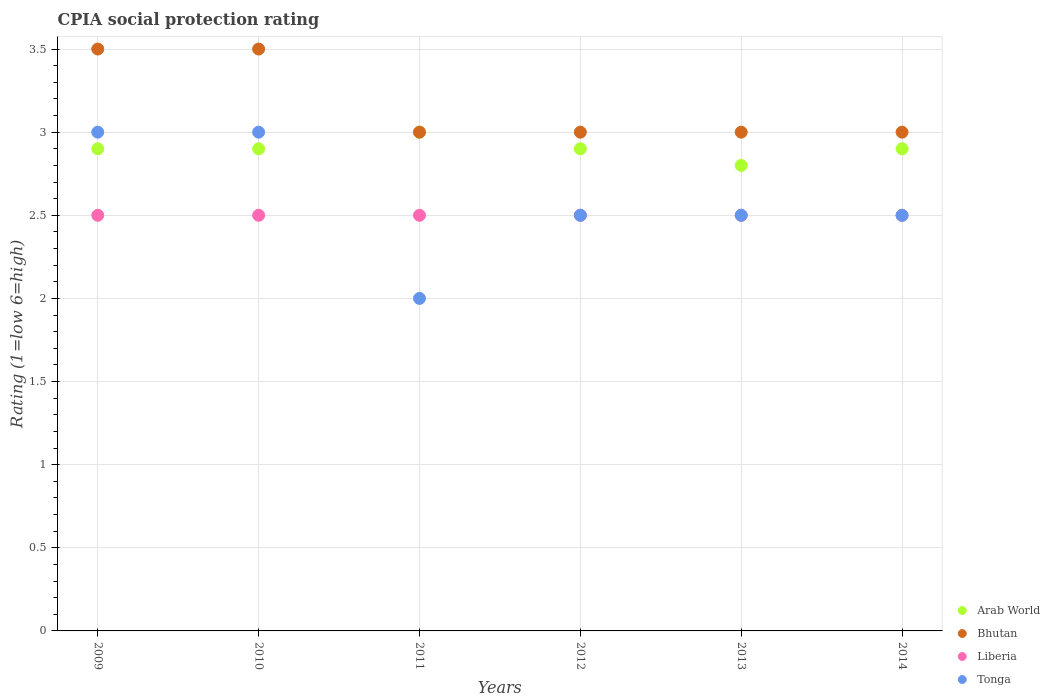How many different coloured dotlines are there?
Offer a terse response. 4. Across all years, what is the maximum CPIA rating in Bhutan?
Your answer should be very brief. 3.5. In which year was the CPIA rating in Liberia maximum?
Give a very brief answer. 2009. In which year was the CPIA rating in Arab World minimum?
Make the answer very short. 2013. What is the difference between the CPIA rating in Arab World in 2013 and that in 2014?
Keep it short and to the point. -0.1. What is the average CPIA rating in Tonga per year?
Give a very brief answer. 2.58. In the year 2011, what is the difference between the CPIA rating in Bhutan and CPIA rating in Tonga?
Ensure brevity in your answer.  1. What is the ratio of the CPIA rating in Arab World in 2010 to that in 2011?
Keep it short and to the point. 0.97. Is the CPIA rating in Arab World in 2013 less than that in 2014?
Your answer should be very brief. Yes. Is the difference between the CPIA rating in Bhutan in 2012 and 2013 greater than the difference between the CPIA rating in Tonga in 2012 and 2013?
Offer a terse response. No. What is the difference between the highest and the second highest CPIA rating in Liberia?
Give a very brief answer. 0. What is the difference between the highest and the lowest CPIA rating in Arab World?
Give a very brief answer. 0.2. In how many years, is the CPIA rating in Tonga greater than the average CPIA rating in Tonga taken over all years?
Ensure brevity in your answer.  2. Is it the case that in every year, the sum of the CPIA rating in Bhutan and CPIA rating in Tonga  is greater than the sum of CPIA rating in Liberia and CPIA rating in Arab World?
Make the answer very short. No. Does the CPIA rating in Arab World monotonically increase over the years?
Offer a very short reply. No. Is the CPIA rating in Bhutan strictly less than the CPIA rating in Arab World over the years?
Give a very brief answer. No. How many dotlines are there?
Your answer should be very brief. 4. Are the values on the major ticks of Y-axis written in scientific E-notation?
Your answer should be very brief. No. Does the graph contain any zero values?
Your answer should be compact. No. Does the graph contain grids?
Your response must be concise. Yes. How are the legend labels stacked?
Your answer should be compact. Vertical. What is the title of the graph?
Provide a succinct answer. CPIA social protection rating. What is the label or title of the X-axis?
Keep it short and to the point. Years. What is the label or title of the Y-axis?
Give a very brief answer. Rating (1=low 6=high). What is the Rating (1=low 6=high) in Tonga in 2010?
Your response must be concise. 3. What is the Rating (1=low 6=high) of Arab World in 2011?
Keep it short and to the point. 3. What is the Rating (1=low 6=high) of Bhutan in 2011?
Your answer should be compact. 3. What is the Rating (1=low 6=high) of Tonga in 2011?
Provide a short and direct response. 2. What is the Rating (1=low 6=high) of Arab World in 2012?
Make the answer very short. 2.9. What is the Rating (1=low 6=high) in Bhutan in 2012?
Make the answer very short. 3. What is the Rating (1=low 6=high) in Tonga in 2012?
Give a very brief answer. 2.5. What is the Rating (1=low 6=high) of Arab World in 2013?
Offer a very short reply. 2.8. What is the Rating (1=low 6=high) in Bhutan in 2013?
Offer a terse response. 3. What is the Rating (1=low 6=high) in Liberia in 2013?
Offer a terse response. 2.5. What is the Rating (1=low 6=high) of Tonga in 2013?
Offer a very short reply. 2.5. What is the Rating (1=low 6=high) in Arab World in 2014?
Ensure brevity in your answer.  2.9. What is the Rating (1=low 6=high) in Tonga in 2014?
Ensure brevity in your answer.  2.5. Across all years, what is the maximum Rating (1=low 6=high) in Bhutan?
Your response must be concise. 3.5. Across all years, what is the minimum Rating (1=low 6=high) in Bhutan?
Offer a terse response. 3. Across all years, what is the minimum Rating (1=low 6=high) in Tonga?
Your response must be concise. 2. What is the total Rating (1=low 6=high) in Arab World in the graph?
Your answer should be very brief. 17.4. What is the total Rating (1=low 6=high) in Bhutan in the graph?
Your answer should be very brief. 19. What is the total Rating (1=low 6=high) of Liberia in the graph?
Offer a very short reply. 15. What is the total Rating (1=low 6=high) of Tonga in the graph?
Your answer should be compact. 15.5. What is the difference between the Rating (1=low 6=high) of Liberia in 2009 and that in 2010?
Make the answer very short. 0. What is the difference between the Rating (1=low 6=high) of Tonga in 2009 and that in 2010?
Offer a very short reply. 0. What is the difference between the Rating (1=low 6=high) of Arab World in 2009 and that in 2011?
Provide a succinct answer. -0.1. What is the difference between the Rating (1=low 6=high) in Bhutan in 2009 and that in 2011?
Offer a terse response. 0.5. What is the difference between the Rating (1=low 6=high) of Arab World in 2009 and that in 2012?
Your answer should be very brief. 0. What is the difference between the Rating (1=low 6=high) in Tonga in 2009 and that in 2012?
Keep it short and to the point. 0.5. What is the difference between the Rating (1=low 6=high) in Arab World in 2009 and that in 2013?
Offer a terse response. 0.1. What is the difference between the Rating (1=low 6=high) of Bhutan in 2009 and that in 2013?
Your response must be concise. 0.5. What is the difference between the Rating (1=low 6=high) in Liberia in 2009 and that in 2013?
Your answer should be very brief. 0. What is the difference between the Rating (1=low 6=high) of Arab World in 2009 and that in 2014?
Your response must be concise. 0. What is the difference between the Rating (1=low 6=high) in Liberia in 2009 and that in 2014?
Give a very brief answer. 0. What is the difference between the Rating (1=low 6=high) of Bhutan in 2010 and that in 2011?
Make the answer very short. 0.5. What is the difference between the Rating (1=low 6=high) of Tonga in 2010 and that in 2011?
Make the answer very short. 1. What is the difference between the Rating (1=low 6=high) of Arab World in 2010 and that in 2012?
Your answer should be very brief. 0. What is the difference between the Rating (1=low 6=high) in Bhutan in 2010 and that in 2012?
Offer a very short reply. 0.5. What is the difference between the Rating (1=low 6=high) of Liberia in 2010 and that in 2012?
Make the answer very short. 0. What is the difference between the Rating (1=low 6=high) in Tonga in 2010 and that in 2012?
Provide a short and direct response. 0.5. What is the difference between the Rating (1=low 6=high) in Arab World in 2010 and that in 2013?
Provide a short and direct response. 0.1. What is the difference between the Rating (1=low 6=high) in Liberia in 2010 and that in 2013?
Your answer should be compact. 0. What is the difference between the Rating (1=low 6=high) in Bhutan in 2010 and that in 2014?
Keep it short and to the point. 0.5. What is the difference between the Rating (1=low 6=high) in Liberia in 2011 and that in 2012?
Your response must be concise. 0. What is the difference between the Rating (1=low 6=high) of Tonga in 2011 and that in 2012?
Make the answer very short. -0.5. What is the difference between the Rating (1=low 6=high) of Bhutan in 2011 and that in 2013?
Ensure brevity in your answer.  0. What is the difference between the Rating (1=low 6=high) in Tonga in 2011 and that in 2013?
Provide a succinct answer. -0.5. What is the difference between the Rating (1=low 6=high) of Arab World in 2011 and that in 2014?
Provide a short and direct response. 0.1. What is the difference between the Rating (1=low 6=high) of Arab World in 2012 and that in 2013?
Your answer should be very brief. 0.1. What is the difference between the Rating (1=low 6=high) of Bhutan in 2012 and that in 2013?
Your answer should be compact. 0. What is the difference between the Rating (1=low 6=high) of Liberia in 2012 and that in 2013?
Your answer should be compact. 0. What is the difference between the Rating (1=low 6=high) of Tonga in 2012 and that in 2013?
Your answer should be very brief. 0. What is the difference between the Rating (1=low 6=high) in Liberia in 2013 and that in 2014?
Your answer should be very brief. 0. What is the difference between the Rating (1=low 6=high) in Arab World in 2009 and the Rating (1=low 6=high) in Bhutan in 2010?
Make the answer very short. -0.6. What is the difference between the Rating (1=low 6=high) of Arab World in 2009 and the Rating (1=low 6=high) of Liberia in 2010?
Your answer should be compact. 0.4. What is the difference between the Rating (1=low 6=high) of Arab World in 2009 and the Rating (1=low 6=high) of Tonga in 2010?
Make the answer very short. -0.1. What is the difference between the Rating (1=low 6=high) in Bhutan in 2009 and the Rating (1=low 6=high) in Tonga in 2010?
Provide a short and direct response. 0.5. What is the difference between the Rating (1=low 6=high) of Arab World in 2009 and the Rating (1=low 6=high) of Liberia in 2011?
Provide a succinct answer. 0.4. What is the difference between the Rating (1=low 6=high) in Bhutan in 2009 and the Rating (1=low 6=high) in Liberia in 2011?
Ensure brevity in your answer.  1. What is the difference between the Rating (1=low 6=high) of Arab World in 2009 and the Rating (1=low 6=high) of Liberia in 2012?
Provide a short and direct response. 0.4. What is the difference between the Rating (1=low 6=high) of Arab World in 2009 and the Rating (1=low 6=high) of Tonga in 2012?
Ensure brevity in your answer.  0.4. What is the difference between the Rating (1=low 6=high) of Bhutan in 2009 and the Rating (1=low 6=high) of Tonga in 2012?
Give a very brief answer. 1. What is the difference between the Rating (1=low 6=high) in Liberia in 2009 and the Rating (1=low 6=high) in Tonga in 2012?
Ensure brevity in your answer.  0. What is the difference between the Rating (1=low 6=high) of Arab World in 2009 and the Rating (1=low 6=high) of Liberia in 2013?
Give a very brief answer. 0.4. What is the difference between the Rating (1=low 6=high) in Arab World in 2009 and the Rating (1=low 6=high) in Tonga in 2013?
Make the answer very short. 0.4. What is the difference between the Rating (1=low 6=high) in Liberia in 2009 and the Rating (1=low 6=high) in Tonga in 2013?
Offer a very short reply. 0. What is the difference between the Rating (1=low 6=high) in Arab World in 2009 and the Rating (1=low 6=high) in Liberia in 2014?
Give a very brief answer. 0.4. What is the difference between the Rating (1=low 6=high) in Arab World in 2009 and the Rating (1=low 6=high) in Tonga in 2014?
Keep it short and to the point. 0.4. What is the difference between the Rating (1=low 6=high) in Bhutan in 2009 and the Rating (1=low 6=high) in Liberia in 2014?
Make the answer very short. 1. What is the difference between the Rating (1=low 6=high) of Liberia in 2009 and the Rating (1=low 6=high) of Tonga in 2014?
Your answer should be very brief. 0. What is the difference between the Rating (1=low 6=high) in Arab World in 2010 and the Rating (1=low 6=high) in Bhutan in 2011?
Provide a short and direct response. -0.1. What is the difference between the Rating (1=low 6=high) in Arab World in 2010 and the Rating (1=low 6=high) in Tonga in 2011?
Ensure brevity in your answer.  0.9. What is the difference between the Rating (1=low 6=high) in Bhutan in 2010 and the Rating (1=low 6=high) in Liberia in 2011?
Offer a terse response. 1. What is the difference between the Rating (1=low 6=high) in Liberia in 2010 and the Rating (1=low 6=high) in Tonga in 2011?
Make the answer very short. 0.5. What is the difference between the Rating (1=low 6=high) of Arab World in 2010 and the Rating (1=low 6=high) of Liberia in 2012?
Make the answer very short. 0.4. What is the difference between the Rating (1=low 6=high) in Bhutan in 2010 and the Rating (1=low 6=high) in Liberia in 2012?
Provide a succinct answer. 1. What is the difference between the Rating (1=low 6=high) in Bhutan in 2010 and the Rating (1=low 6=high) in Tonga in 2012?
Make the answer very short. 1. What is the difference between the Rating (1=low 6=high) of Bhutan in 2010 and the Rating (1=low 6=high) of Liberia in 2013?
Your response must be concise. 1. What is the difference between the Rating (1=low 6=high) in Bhutan in 2010 and the Rating (1=low 6=high) in Tonga in 2013?
Ensure brevity in your answer.  1. What is the difference between the Rating (1=low 6=high) of Arab World in 2010 and the Rating (1=low 6=high) of Liberia in 2014?
Your response must be concise. 0.4. What is the difference between the Rating (1=low 6=high) of Arab World in 2010 and the Rating (1=low 6=high) of Tonga in 2014?
Offer a very short reply. 0.4. What is the difference between the Rating (1=low 6=high) of Bhutan in 2010 and the Rating (1=low 6=high) of Tonga in 2014?
Your answer should be very brief. 1. What is the difference between the Rating (1=low 6=high) of Arab World in 2011 and the Rating (1=low 6=high) of Liberia in 2012?
Ensure brevity in your answer.  0.5. What is the difference between the Rating (1=low 6=high) in Arab World in 2011 and the Rating (1=low 6=high) in Tonga in 2012?
Offer a terse response. 0.5. What is the difference between the Rating (1=low 6=high) of Bhutan in 2011 and the Rating (1=low 6=high) of Liberia in 2012?
Make the answer very short. 0.5. What is the difference between the Rating (1=low 6=high) of Arab World in 2011 and the Rating (1=low 6=high) of Liberia in 2013?
Keep it short and to the point. 0.5. What is the difference between the Rating (1=low 6=high) in Bhutan in 2011 and the Rating (1=low 6=high) in Liberia in 2013?
Your answer should be very brief. 0.5. What is the difference between the Rating (1=low 6=high) in Bhutan in 2011 and the Rating (1=low 6=high) in Tonga in 2013?
Offer a terse response. 0.5. What is the difference between the Rating (1=low 6=high) in Liberia in 2011 and the Rating (1=low 6=high) in Tonga in 2013?
Give a very brief answer. 0. What is the difference between the Rating (1=low 6=high) in Arab World in 2011 and the Rating (1=low 6=high) in Bhutan in 2014?
Your answer should be very brief. 0. What is the difference between the Rating (1=low 6=high) of Bhutan in 2011 and the Rating (1=low 6=high) of Tonga in 2014?
Make the answer very short. 0.5. What is the difference between the Rating (1=low 6=high) in Arab World in 2012 and the Rating (1=low 6=high) in Bhutan in 2013?
Offer a very short reply. -0.1. What is the difference between the Rating (1=low 6=high) in Bhutan in 2012 and the Rating (1=low 6=high) in Tonga in 2013?
Your answer should be compact. 0.5. What is the difference between the Rating (1=low 6=high) of Liberia in 2012 and the Rating (1=low 6=high) of Tonga in 2013?
Your answer should be very brief. 0. What is the difference between the Rating (1=low 6=high) in Arab World in 2012 and the Rating (1=low 6=high) in Bhutan in 2014?
Offer a terse response. -0.1. What is the difference between the Rating (1=low 6=high) in Arab World in 2012 and the Rating (1=low 6=high) in Liberia in 2014?
Offer a terse response. 0.4. What is the difference between the Rating (1=low 6=high) of Arab World in 2012 and the Rating (1=low 6=high) of Tonga in 2014?
Ensure brevity in your answer.  0.4. What is the difference between the Rating (1=low 6=high) of Bhutan in 2012 and the Rating (1=low 6=high) of Liberia in 2014?
Make the answer very short. 0.5. What is the difference between the Rating (1=low 6=high) of Liberia in 2012 and the Rating (1=low 6=high) of Tonga in 2014?
Your answer should be very brief. 0. What is the difference between the Rating (1=low 6=high) in Arab World in 2013 and the Rating (1=low 6=high) in Liberia in 2014?
Offer a terse response. 0.3. What is the difference between the Rating (1=low 6=high) in Arab World in 2013 and the Rating (1=low 6=high) in Tonga in 2014?
Ensure brevity in your answer.  0.3. What is the difference between the Rating (1=low 6=high) in Bhutan in 2013 and the Rating (1=low 6=high) in Liberia in 2014?
Give a very brief answer. 0.5. What is the difference between the Rating (1=low 6=high) of Bhutan in 2013 and the Rating (1=low 6=high) of Tonga in 2014?
Keep it short and to the point. 0.5. What is the average Rating (1=low 6=high) of Arab World per year?
Provide a short and direct response. 2.9. What is the average Rating (1=low 6=high) of Bhutan per year?
Provide a short and direct response. 3.17. What is the average Rating (1=low 6=high) of Tonga per year?
Keep it short and to the point. 2.58. In the year 2009, what is the difference between the Rating (1=low 6=high) of Arab World and Rating (1=low 6=high) of Liberia?
Your answer should be very brief. 0.4. In the year 2009, what is the difference between the Rating (1=low 6=high) of Bhutan and Rating (1=low 6=high) of Liberia?
Ensure brevity in your answer.  1. In the year 2010, what is the difference between the Rating (1=low 6=high) of Arab World and Rating (1=low 6=high) of Bhutan?
Make the answer very short. -0.6. In the year 2010, what is the difference between the Rating (1=low 6=high) of Arab World and Rating (1=low 6=high) of Tonga?
Make the answer very short. -0.1. In the year 2010, what is the difference between the Rating (1=low 6=high) of Liberia and Rating (1=low 6=high) of Tonga?
Ensure brevity in your answer.  -0.5. In the year 2011, what is the difference between the Rating (1=low 6=high) in Arab World and Rating (1=low 6=high) in Bhutan?
Provide a short and direct response. 0. In the year 2011, what is the difference between the Rating (1=low 6=high) of Arab World and Rating (1=low 6=high) of Tonga?
Keep it short and to the point. 1. In the year 2011, what is the difference between the Rating (1=low 6=high) in Bhutan and Rating (1=low 6=high) in Tonga?
Your response must be concise. 1. In the year 2012, what is the difference between the Rating (1=low 6=high) in Arab World and Rating (1=low 6=high) in Bhutan?
Provide a succinct answer. -0.1. In the year 2012, what is the difference between the Rating (1=low 6=high) of Arab World and Rating (1=low 6=high) of Liberia?
Your response must be concise. 0.4. In the year 2012, what is the difference between the Rating (1=low 6=high) of Arab World and Rating (1=low 6=high) of Tonga?
Offer a very short reply. 0.4. In the year 2012, what is the difference between the Rating (1=low 6=high) in Liberia and Rating (1=low 6=high) in Tonga?
Ensure brevity in your answer.  0. In the year 2013, what is the difference between the Rating (1=low 6=high) in Arab World and Rating (1=low 6=high) in Bhutan?
Give a very brief answer. -0.2. In the year 2013, what is the difference between the Rating (1=low 6=high) of Arab World and Rating (1=low 6=high) of Tonga?
Offer a terse response. 0.3. In the year 2013, what is the difference between the Rating (1=low 6=high) in Bhutan and Rating (1=low 6=high) in Liberia?
Ensure brevity in your answer.  0.5. In the year 2013, what is the difference between the Rating (1=low 6=high) of Bhutan and Rating (1=low 6=high) of Tonga?
Offer a very short reply. 0.5. In the year 2014, what is the difference between the Rating (1=low 6=high) in Arab World and Rating (1=low 6=high) in Bhutan?
Ensure brevity in your answer.  -0.1. In the year 2014, what is the difference between the Rating (1=low 6=high) in Bhutan and Rating (1=low 6=high) in Liberia?
Your answer should be very brief. 0.5. In the year 2014, what is the difference between the Rating (1=low 6=high) in Bhutan and Rating (1=low 6=high) in Tonga?
Your response must be concise. 0.5. What is the ratio of the Rating (1=low 6=high) in Tonga in 2009 to that in 2010?
Provide a succinct answer. 1. What is the ratio of the Rating (1=low 6=high) of Arab World in 2009 to that in 2011?
Ensure brevity in your answer.  0.97. What is the ratio of the Rating (1=low 6=high) of Tonga in 2009 to that in 2011?
Provide a short and direct response. 1.5. What is the ratio of the Rating (1=low 6=high) in Bhutan in 2009 to that in 2012?
Ensure brevity in your answer.  1.17. What is the ratio of the Rating (1=low 6=high) of Liberia in 2009 to that in 2012?
Offer a terse response. 1. What is the ratio of the Rating (1=low 6=high) of Tonga in 2009 to that in 2012?
Your answer should be compact. 1.2. What is the ratio of the Rating (1=low 6=high) in Arab World in 2009 to that in 2013?
Make the answer very short. 1.04. What is the ratio of the Rating (1=low 6=high) in Bhutan in 2009 to that in 2013?
Offer a terse response. 1.17. What is the ratio of the Rating (1=low 6=high) of Tonga in 2009 to that in 2013?
Your response must be concise. 1.2. What is the ratio of the Rating (1=low 6=high) of Arab World in 2009 to that in 2014?
Your answer should be compact. 1. What is the ratio of the Rating (1=low 6=high) in Bhutan in 2009 to that in 2014?
Offer a terse response. 1.17. What is the ratio of the Rating (1=low 6=high) of Tonga in 2009 to that in 2014?
Your response must be concise. 1.2. What is the ratio of the Rating (1=low 6=high) in Arab World in 2010 to that in 2011?
Provide a short and direct response. 0.97. What is the ratio of the Rating (1=low 6=high) of Bhutan in 2010 to that in 2011?
Offer a terse response. 1.17. What is the ratio of the Rating (1=low 6=high) of Liberia in 2010 to that in 2011?
Make the answer very short. 1. What is the ratio of the Rating (1=low 6=high) in Tonga in 2010 to that in 2011?
Give a very brief answer. 1.5. What is the ratio of the Rating (1=low 6=high) in Arab World in 2010 to that in 2012?
Keep it short and to the point. 1. What is the ratio of the Rating (1=low 6=high) of Bhutan in 2010 to that in 2012?
Your response must be concise. 1.17. What is the ratio of the Rating (1=low 6=high) of Tonga in 2010 to that in 2012?
Provide a short and direct response. 1.2. What is the ratio of the Rating (1=low 6=high) in Arab World in 2010 to that in 2013?
Make the answer very short. 1.04. What is the ratio of the Rating (1=low 6=high) of Bhutan in 2010 to that in 2013?
Your answer should be very brief. 1.17. What is the ratio of the Rating (1=low 6=high) in Liberia in 2010 to that in 2013?
Your response must be concise. 1. What is the ratio of the Rating (1=low 6=high) in Tonga in 2010 to that in 2013?
Your answer should be compact. 1.2. What is the ratio of the Rating (1=low 6=high) of Bhutan in 2010 to that in 2014?
Offer a very short reply. 1.17. What is the ratio of the Rating (1=low 6=high) in Liberia in 2010 to that in 2014?
Your answer should be compact. 1. What is the ratio of the Rating (1=low 6=high) in Arab World in 2011 to that in 2012?
Provide a short and direct response. 1.03. What is the ratio of the Rating (1=low 6=high) in Liberia in 2011 to that in 2012?
Your answer should be compact. 1. What is the ratio of the Rating (1=low 6=high) of Arab World in 2011 to that in 2013?
Offer a very short reply. 1.07. What is the ratio of the Rating (1=low 6=high) in Bhutan in 2011 to that in 2013?
Your answer should be very brief. 1. What is the ratio of the Rating (1=low 6=high) in Liberia in 2011 to that in 2013?
Provide a succinct answer. 1. What is the ratio of the Rating (1=low 6=high) in Arab World in 2011 to that in 2014?
Your answer should be very brief. 1.03. What is the ratio of the Rating (1=low 6=high) of Arab World in 2012 to that in 2013?
Make the answer very short. 1.04. What is the ratio of the Rating (1=low 6=high) of Bhutan in 2012 to that in 2013?
Provide a succinct answer. 1. What is the ratio of the Rating (1=low 6=high) in Tonga in 2012 to that in 2013?
Your answer should be compact. 1. What is the ratio of the Rating (1=low 6=high) in Arab World in 2012 to that in 2014?
Provide a succinct answer. 1. What is the ratio of the Rating (1=low 6=high) in Bhutan in 2012 to that in 2014?
Offer a terse response. 1. What is the ratio of the Rating (1=low 6=high) in Liberia in 2012 to that in 2014?
Offer a terse response. 1. What is the ratio of the Rating (1=low 6=high) in Tonga in 2012 to that in 2014?
Your response must be concise. 1. What is the ratio of the Rating (1=low 6=high) in Arab World in 2013 to that in 2014?
Keep it short and to the point. 0.97. What is the ratio of the Rating (1=low 6=high) in Bhutan in 2013 to that in 2014?
Provide a succinct answer. 1. What is the ratio of the Rating (1=low 6=high) of Liberia in 2013 to that in 2014?
Keep it short and to the point. 1. What is the ratio of the Rating (1=low 6=high) in Tonga in 2013 to that in 2014?
Ensure brevity in your answer.  1. What is the difference between the highest and the second highest Rating (1=low 6=high) of Tonga?
Make the answer very short. 0. What is the difference between the highest and the lowest Rating (1=low 6=high) of Liberia?
Your response must be concise. 0. 